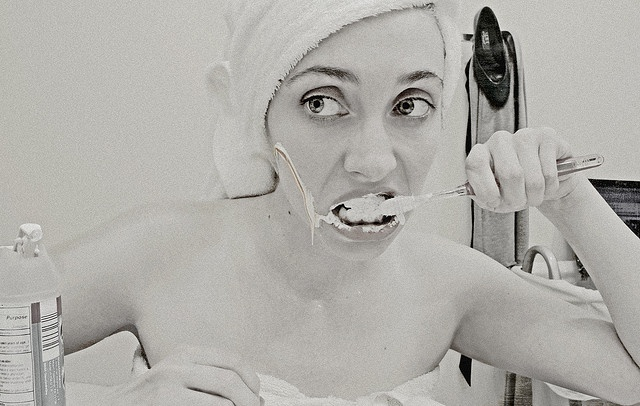Describe the objects in this image and their specific colors. I can see people in darkgray and lightgray tones, bottle in darkgray, lightgray, and gray tones, and toothbrush in darkgray, lightgray, and gray tones in this image. 